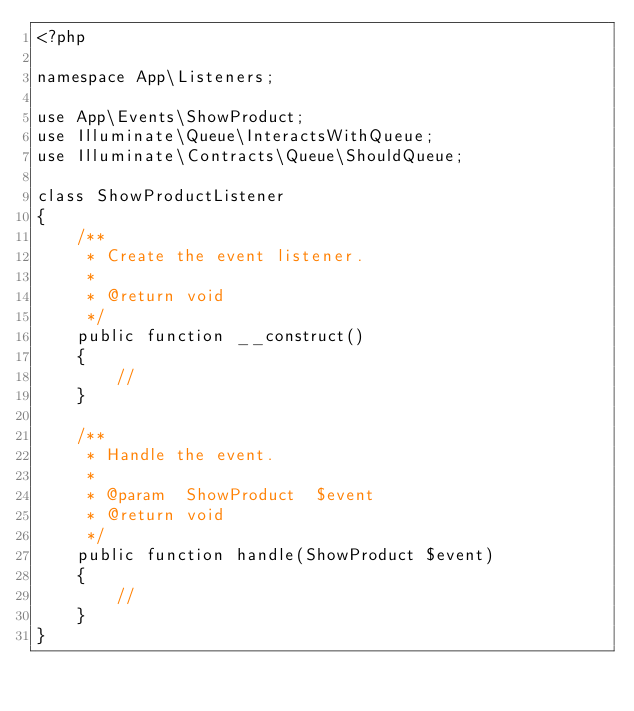Convert code to text. <code><loc_0><loc_0><loc_500><loc_500><_PHP_><?php

namespace App\Listeners;

use App\Events\ShowProduct;
use Illuminate\Queue\InteractsWithQueue;
use Illuminate\Contracts\Queue\ShouldQueue;

class ShowProductListener
{
    /**
     * Create the event listener.
     *
     * @return void
     */
    public function __construct()
    {
        //
    }

    /**
     * Handle the event.
     *
     * @param  ShowProduct  $event
     * @return void
     */
    public function handle(ShowProduct $event)
    {
        //
    }
}
</code> 